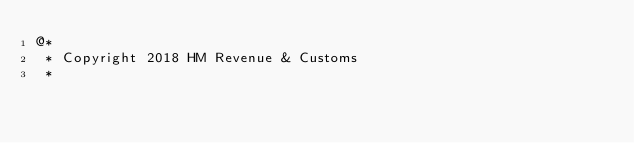<code> <loc_0><loc_0><loc_500><loc_500><_HTML_>@*
 * Copyright 2018 HM Revenue & Customs
 *</code> 